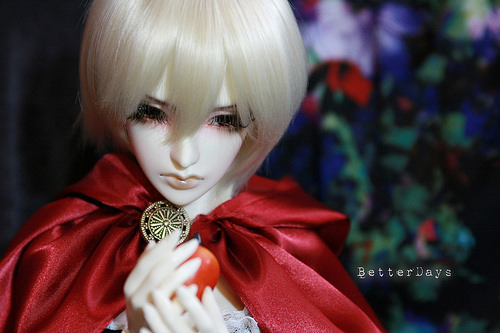<image>
Is the brooch behind the wall? No. The brooch is not behind the wall. From this viewpoint, the brooch appears to be positioned elsewhere in the scene. 